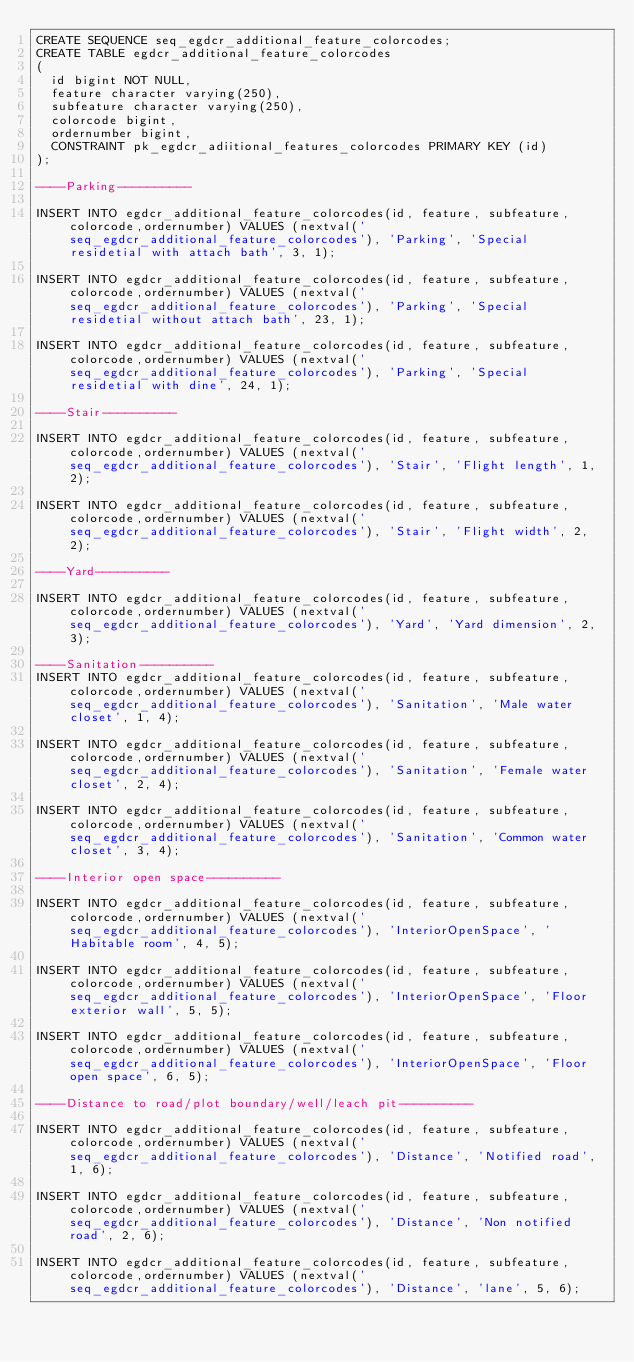Convert code to text. <code><loc_0><loc_0><loc_500><loc_500><_SQL_>CREATE SEQUENCE seq_egdcr_additional_feature_colorcodes;
CREATE TABLE egdcr_additional_feature_colorcodes
(
  id bigint NOT NULL,
  feature character varying(250),
  subfeature character varying(250),
  colorcode bigint,
  ordernumber bigint,
  CONSTRAINT pk_egdcr_adiitional_features_colorcodes PRIMARY KEY (id)
);

----Parking----------

INSERT INTO egdcr_additional_feature_colorcodes(id, feature, subfeature, colorcode,ordernumber) VALUES (nextval('seq_egdcr_additional_feature_colorcodes'), 'Parking', 'Special residetial with attach bath', 3, 1);

INSERT INTO egdcr_additional_feature_colorcodes(id, feature, subfeature, colorcode,ordernumber) VALUES (nextval('seq_egdcr_additional_feature_colorcodes'), 'Parking', 'Special residetial without attach bath', 23, 1);

INSERT INTO egdcr_additional_feature_colorcodes(id, feature, subfeature, colorcode,ordernumber) VALUES (nextval('seq_egdcr_additional_feature_colorcodes'), 'Parking', 'Special residetial with dine', 24, 1);

----Stair----------

INSERT INTO egdcr_additional_feature_colorcodes(id, feature, subfeature, colorcode,ordernumber) VALUES (nextval('seq_egdcr_additional_feature_colorcodes'), 'Stair', 'Flight length', 1, 2);

INSERT INTO egdcr_additional_feature_colorcodes(id, feature, subfeature, colorcode,ordernumber) VALUES (nextval('seq_egdcr_additional_feature_colorcodes'), 'Stair', 'Flight width', 2, 2);

----Yard----------

INSERT INTO egdcr_additional_feature_colorcodes(id, feature, subfeature, colorcode,ordernumber) VALUES (nextval('seq_egdcr_additional_feature_colorcodes'), 'Yard', 'Yard dimension', 2, 3);

----Sanitation----------
INSERT INTO egdcr_additional_feature_colorcodes(id, feature, subfeature, colorcode,ordernumber) VALUES (nextval('seq_egdcr_additional_feature_colorcodes'), 'Sanitation', 'Male water closet', 1, 4);

INSERT INTO egdcr_additional_feature_colorcodes(id, feature, subfeature, colorcode,ordernumber) VALUES (nextval('seq_egdcr_additional_feature_colorcodes'), 'Sanitation', 'Female water closet', 2, 4);

INSERT INTO egdcr_additional_feature_colorcodes(id, feature, subfeature, colorcode,ordernumber) VALUES (nextval('seq_egdcr_additional_feature_colorcodes'), 'Sanitation', 'Common water closet', 3, 4);

----Interior open space----------

INSERT INTO egdcr_additional_feature_colorcodes(id, feature, subfeature, colorcode,ordernumber) VALUES (nextval('seq_egdcr_additional_feature_colorcodes'), 'InteriorOpenSpace', 'Habitable room', 4, 5);

INSERT INTO egdcr_additional_feature_colorcodes(id, feature, subfeature, colorcode,ordernumber) VALUES (nextval('seq_egdcr_additional_feature_colorcodes'), 'InteriorOpenSpace', 'Floor exterior wall', 5, 5);

INSERT INTO egdcr_additional_feature_colorcodes(id, feature, subfeature, colorcode,ordernumber) VALUES (nextval('seq_egdcr_additional_feature_colorcodes'), 'InteriorOpenSpace', 'Floor open space', 6, 5);

----Distance to road/plot boundary/well/leach pit----------

INSERT INTO egdcr_additional_feature_colorcodes(id, feature, subfeature, colorcode,ordernumber) VALUES (nextval('seq_egdcr_additional_feature_colorcodes'), 'Distance', 'Notified road', 1, 6);

INSERT INTO egdcr_additional_feature_colorcodes(id, feature, subfeature, colorcode,ordernumber) VALUES (nextval('seq_egdcr_additional_feature_colorcodes'), 'Distance', 'Non notified road', 2, 6);

INSERT INTO egdcr_additional_feature_colorcodes(id, feature, subfeature, colorcode,ordernumber) VALUES (nextval('seq_egdcr_additional_feature_colorcodes'), 'Distance', 'lane', 5, 6);
</code> 